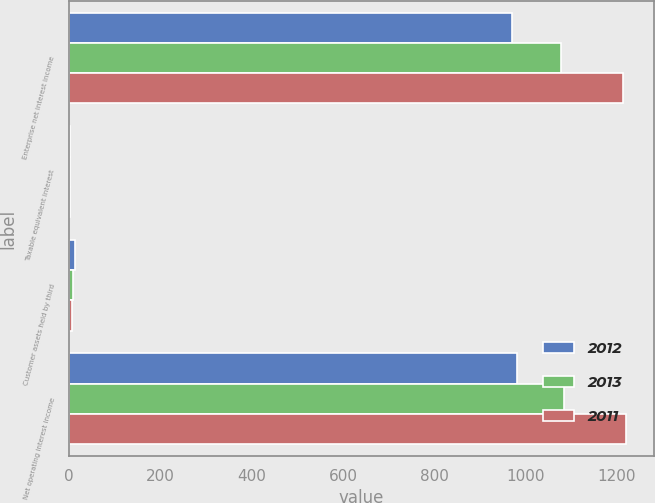Convert chart to OTSL. <chart><loc_0><loc_0><loc_500><loc_500><stacked_bar_chart><ecel><fcel>Enterprise net interest income<fcel>Taxable equivalent interest<fcel>Customer assets held by third<fcel>Net operating interest income<nl><fcel>2012<fcel>970.4<fcel>1<fcel>12.4<fcel>981.8<nl><fcel>2013<fcel>1077.7<fcel>1.1<fcel>8.5<fcel>1085.1<nl><fcel>2011<fcel>1213.9<fcel>1.2<fcel>7.3<fcel>1220<nl></chart> 